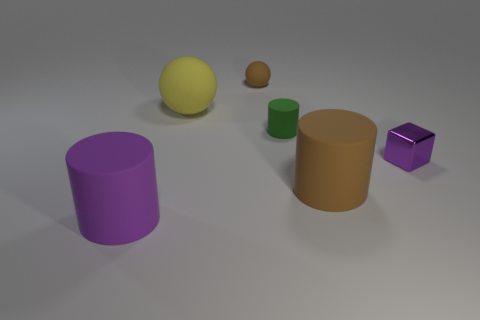Are there any other things that have the same material as the small purple block?
Provide a succinct answer. No. How many small balls are the same color as the metal object?
Give a very brief answer. 0. There is a large sphere that is made of the same material as the tiny ball; what is its color?
Offer a very short reply. Yellow. Are there any cyan metal cubes of the same size as the brown sphere?
Offer a very short reply. No. Are there more purple matte things that are on the right side of the purple block than small objects that are on the right side of the small brown ball?
Provide a succinct answer. No. Is the material of the purple thing that is on the right side of the big sphere the same as the big object behind the metallic object?
Provide a succinct answer. No. What shape is the brown rubber thing that is the same size as the yellow matte object?
Provide a short and direct response. Cylinder. Are there any large objects of the same shape as the tiny green object?
Make the answer very short. Yes. Is the color of the large cylinder that is on the left side of the tiny green rubber cylinder the same as the big object that is right of the big ball?
Offer a terse response. No. Are there any tiny green matte things behind the tiny matte sphere?
Provide a succinct answer. No. 